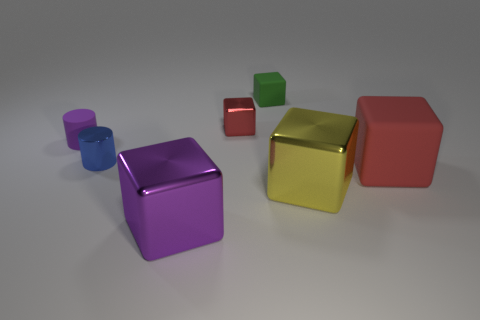Subtract all tiny metal blocks. How many blocks are left? 4 Subtract all purple cubes. How many cubes are left? 4 Subtract all brown cubes. Subtract all gray spheres. How many cubes are left? 5 Add 1 tiny green things. How many objects exist? 8 Subtract all blocks. How many objects are left? 2 Add 5 purple rubber cylinders. How many purple rubber cylinders are left? 6 Add 5 metal things. How many metal things exist? 9 Subtract 1 purple cylinders. How many objects are left? 6 Subtract all green cylinders. Subtract all small red metal things. How many objects are left? 6 